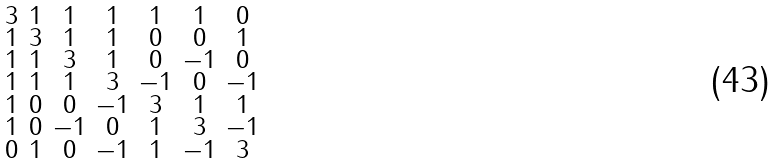<formula> <loc_0><loc_0><loc_500><loc_500>\begin{smallmatrix} 3 & 1 & 1 & 1 & 1 & 1 & 0 \\ 1 & 3 & 1 & 1 & 0 & 0 & 1 \\ 1 & 1 & 3 & 1 & 0 & - 1 & 0 \\ 1 & 1 & 1 & 3 & - 1 & 0 & - 1 \\ 1 & 0 & 0 & - 1 & 3 & 1 & 1 \\ 1 & 0 & - 1 & 0 & 1 & 3 & - 1 \\ 0 & 1 & 0 & - 1 & 1 & - 1 & 3 \end{smallmatrix}</formula> 